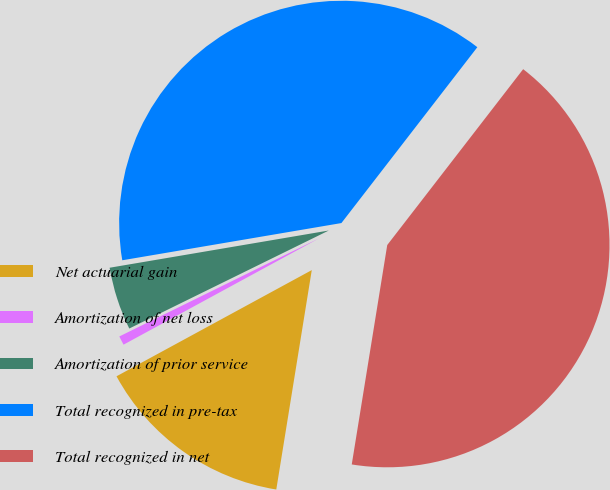Convert chart to OTSL. <chart><loc_0><loc_0><loc_500><loc_500><pie_chart><fcel>Net actuarial gain<fcel>Amortization of net loss<fcel>Amortization of prior service<fcel>Total recognized in pre-tax<fcel>Total recognized in net<nl><fcel>14.52%<fcel>0.66%<fcel>4.59%<fcel>38.15%<fcel>42.08%<nl></chart> 